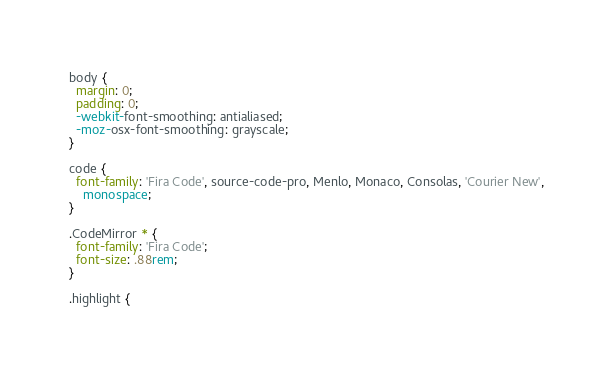<code> <loc_0><loc_0><loc_500><loc_500><_CSS_>body {
  margin: 0;
  padding: 0;
  -webkit-font-smoothing: antialiased;
  -moz-osx-font-smoothing: grayscale;
}

code {
  font-family: 'Fira Code', source-code-pro, Menlo, Monaco, Consolas, 'Courier New',
    monospace;
}

.CodeMirror * {
  font-family: 'Fira Code';
  font-size: .88rem;
}

.highlight {</code> 